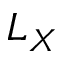Convert formula to latex. <formula><loc_0><loc_0><loc_500><loc_500>L _ { X }</formula> 